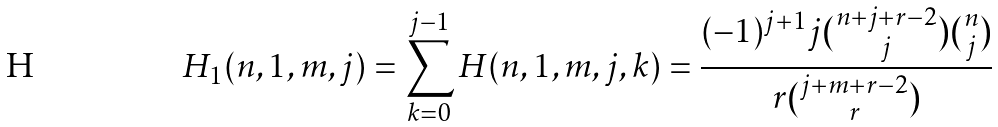<formula> <loc_0><loc_0><loc_500><loc_500>H _ { 1 } ( n , 1 , m , j ) = \sum _ { k = 0 } ^ { j - 1 } H ( n , 1 , m , j , k ) = \frac { ( - 1 ) ^ { j + 1 } j \binom { n + j + r - 2 } { j } \binom { n } { j } } { r \binom { j + m + r - 2 } { r } }</formula> 